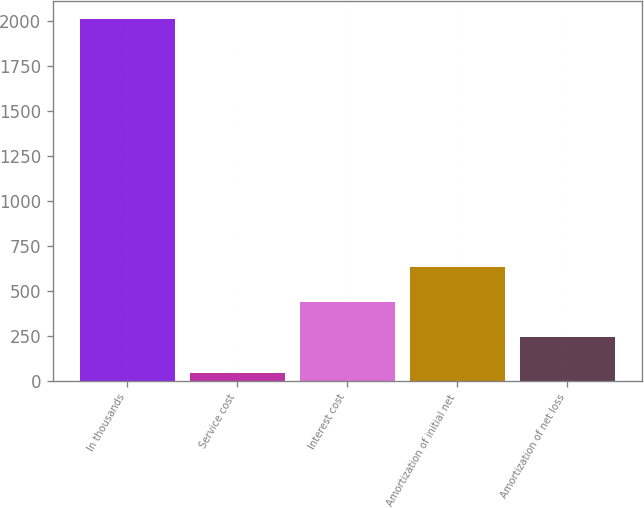Convert chart. <chart><loc_0><loc_0><loc_500><loc_500><bar_chart><fcel>In thousands<fcel>Service cost<fcel>Interest cost<fcel>Amortization of initial net<fcel>Amortization of net loss<nl><fcel>2012<fcel>45<fcel>438.4<fcel>635.1<fcel>241.7<nl></chart> 